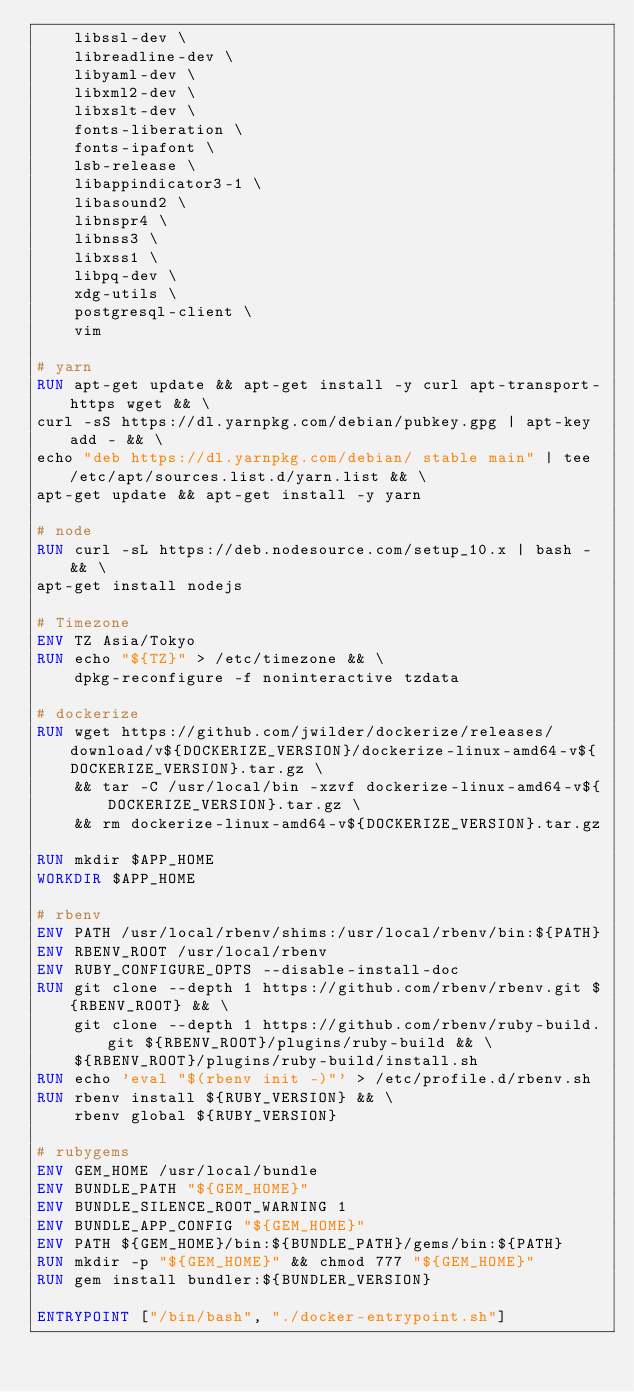<code> <loc_0><loc_0><loc_500><loc_500><_Dockerfile_>    libssl-dev \
    libreadline-dev \
    libyaml-dev \
    libxml2-dev \
    libxslt-dev \
    fonts-liberation \
    fonts-ipafont \
    lsb-release \
    libappindicator3-1 \
    libasound2 \
    libnspr4 \
    libnss3 \
    libxss1 \
    libpq-dev \
    xdg-utils \
    postgresql-client \
    vim

# yarn
RUN apt-get update && apt-get install -y curl apt-transport-https wget && \
curl -sS https://dl.yarnpkg.com/debian/pubkey.gpg | apt-key add - && \
echo "deb https://dl.yarnpkg.com/debian/ stable main" | tee /etc/apt/sources.list.d/yarn.list && \
apt-get update && apt-get install -y yarn

# node
RUN curl -sL https://deb.nodesource.com/setup_10.x | bash - && \
apt-get install nodejs

# Timezone
ENV TZ Asia/Tokyo
RUN echo "${TZ}" > /etc/timezone && \
    dpkg-reconfigure -f noninteractive tzdata

# dockerize
RUN wget https://github.com/jwilder/dockerize/releases/download/v${DOCKERIZE_VERSION}/dockerize-linux-amd64-v${DOCKERIZE_VERSION}.tar.gz \
    && tar -C /usr/local/bin -xzvf dockerize-linux-amd64-v${DOCKERIZE_VERSION}.tar.gz \
    && rm dockerize-linux-amd64-v${DOCKERIZE_VERSION}.tar.gz

RUN mkdir $APP_HOME
WORKDIR $APP_HOME

# rbenv
ENV PATH /usr/local/rbenv/shims:/usr/local/rbenv/bin:${PATH}
ENV RBENV_ROOT /usr/local/rbenv
ENV RUBY_CONFIGURE_OPTS --disable-install-doc
RUN git clone --depth 1 https://github.com/rbenv/rbenv.git ${RBENV_ROOT} && \
    git clone --depth 1 https://github.com/rbenv/ruby-build.git ${RBENV_ROOT}/plugins/ruby-build && \
    ${RBENV_ROOT}/plugins/ruby-build/install.sh
RUN echo 'eval "$(rbenv init -)"' > /etc/profile.d/rbenv.sh
RUN rbenv install ${RUBY_VERSION} && \
    rbenv global ${RUBY_VERSION}

# rubygems
ENV GEM_HOME /usr/local/bundle
ENV BUNDLE_PATH "${GEM_HOME}"
ENV BUNDLE_SILENCE_ROOT_WARNING 1
ENV BUNDLE_APP_CONFIG "${GEM_HOME}"
ENV PATH ${GEM_HOME}/bin:${BUNDLE_PATH}/gems/bin:${PATH}
RUN mkdir -p "${GEM_HOME}" && chmod 777 "${GEM_HOME}"
RUN gem install bundler:${BUNDLER_VERSION}

ENTRYPOINT ["/bin/bash", "./docker-entrypoint.sh"]
</code> 